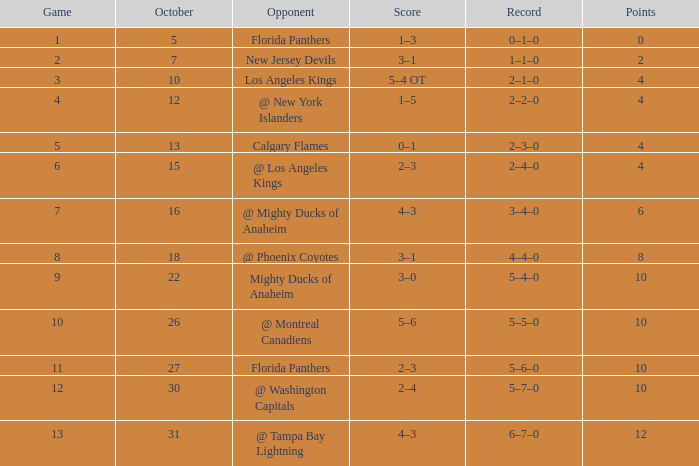Which group possesses a score of 2? 3–1. 